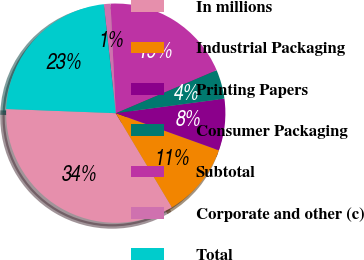Convert chart to OTSL. <chart><loc_0><loc_0><loc_500><loc_500><pie_chart><fcel>In millions<fcel>Industrial Packaging<fcel>Printing Papers<fcel>Consumer Packaging<fcel>Subtotal<fcel>Corporate and other (c)<fcel>Total<nl><fcel>34.16%<fcel>10.94%<fcel>7.62%<fcel>4.3%<fcel>19.34%<fcel>0.98%<fcel>22.66%<nl></chart> 